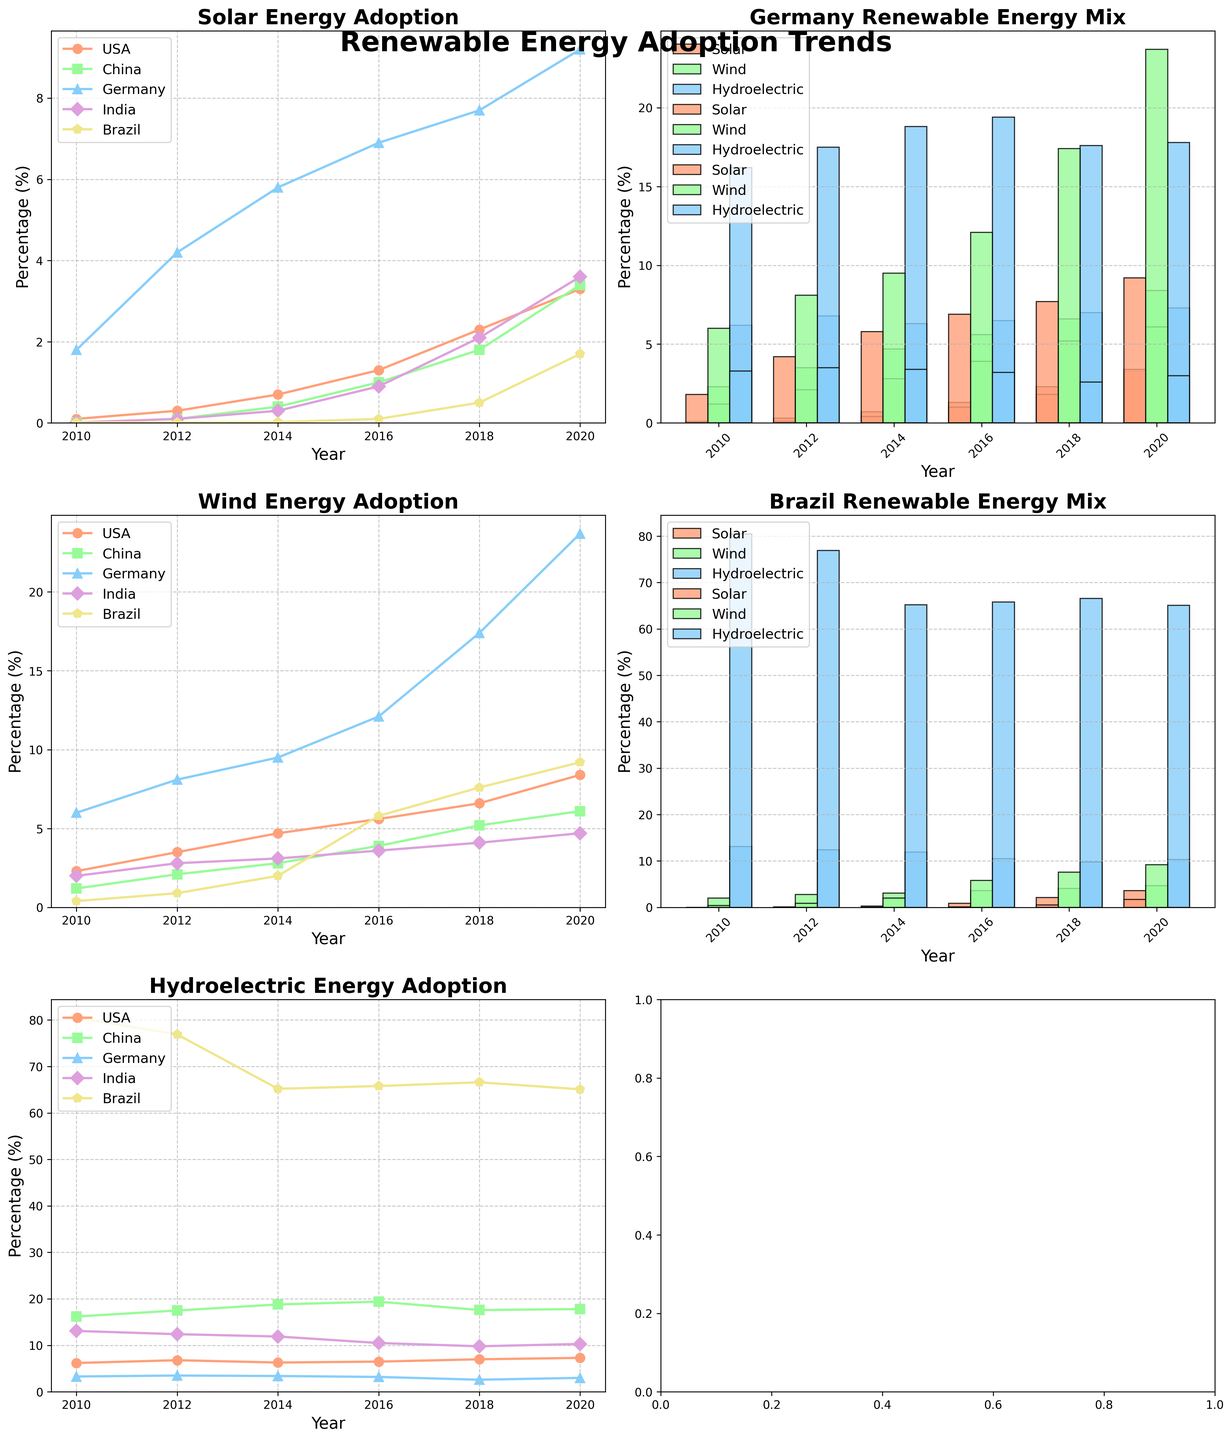Which country's solar energy adoption grew the fastest between 2010 and 2020? To determine which country's solar energy adoption grew the fastest, we need to calculate the difference in solar energy percentage from 2020 and 2010 for each country and then compare them. For China, the increase is 3.4 - 0.01 = 3.39%. For the USA, it is 3.3 - 0.1 = 3.2%. For Germany, it is 9.2 - 1.8 = 7.4%. For India, it is 3.6 - 0.01 = 3.59%. For Brazil, it is 1.7 - 0.01 = 1.69%. Germany has the highest increase.
Answer: Germany Which renewable energy source had the highest adoption in Brazil in 2020? By referring to the bar chart for Brazil, we can see the heights of the bars representing different energy sources in 2020. The hydroelectric bar is the tallest.
Answer: Hydroelectric Which country showed the most significant growth in wind energy adoption between 2010 and 2020? To find the country with the most significant growth in wind energy from 2010 to 2020, we subtract the 2010 values from the 2020 values for each country. For the USA, 8.4 - 2.3 = 6.1%. For China, 6.1 - 1.2 = 4.9%. For Germany, 23.7 - 6.0 = 17.7%. For India, 4.7 - 2.0 = 2.7%. For Brazil, 9.2 - 0.4 = 8.8%. Germany has the highest growth.
Answer: Germany Which energy source had the least percentage contribution in India in 2020? By looking at the heights of the bars in the 2020 section for India, the shortest bar represents the least percentage contribution. Solar energy has the shortest bar.
Answer: Solar In 2018, which country had the highest percentage of wind energy adoption? We need to compare the heights of the wind energy lines for 2018. Germany's line is the highest at 17.4% in 2018.
Answer: Germany How did the adoption of hydroelectric energy change in China from 2010 to 2020? To find the change, subtract the hydroelectric percentage in 2010 from the percentage in 2020 for China. The change is 17.8 - 16.2 = 1.6%.
Answer: Increased by 1.6% In which year did solar energy adoption in the USA surpass 1%? We need to observe the trend line for solar energy adoption in the USA and identify the year it first surpasses 1%. This occurs between 2014 and 2016. In 2016, it reaches 1.3%.
Answer: 2016 In 2020, which country had the highest overall renewable energy adoption for all three sources combined? Sum the percentages of Solar, Wind, and Hydroelectric for each country in 2020, and compare. For the USA: 3.3 + 8.4 + 7.3 = 19%. For China: 3.4 + 6.1 + 17.8 = 27.3%. For Germany: 9.2 + 23.7 + 3.0 = 35.9%. For India: 3.6 + 4.7 + 10.3 = 18.6%. For Brazil: 1.7 + 9.2 + 65.1 = 76%. Brazil has the highest combined adoption.
Answer: Brazil Among the shown years, in what year did Germany have the highest increase in wind energy adoption compared to the previous measurement? Compare the increases in wind energy adoption in the shown years for Germany. The highest increase occurred between 2018 and 2020, from 17.4 to 23.7, with an increase of 6.3%.
Answer: 2018-2020 